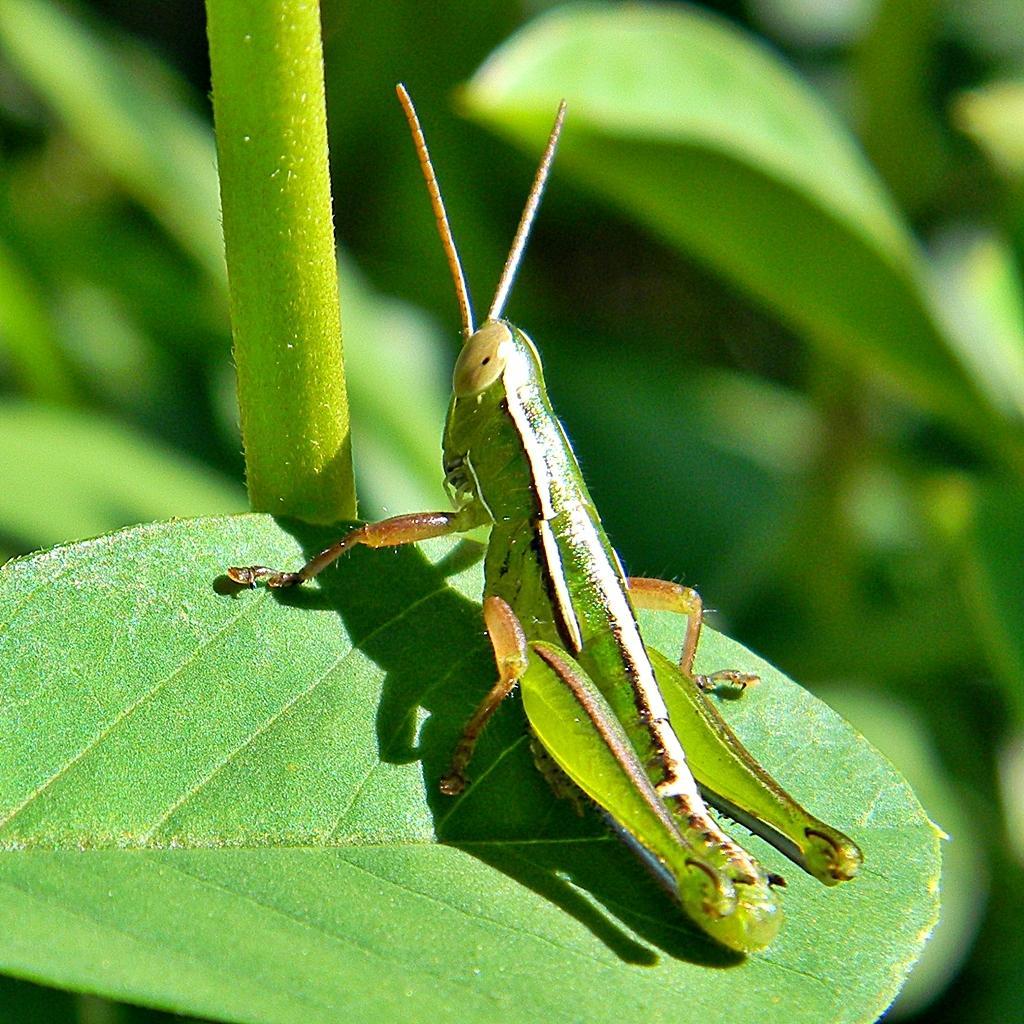Could you give a brief overview of what you see in this image? There is an insect on a leaf we can see at the bottom of this image, and there is a stem and other leaves in the background. 